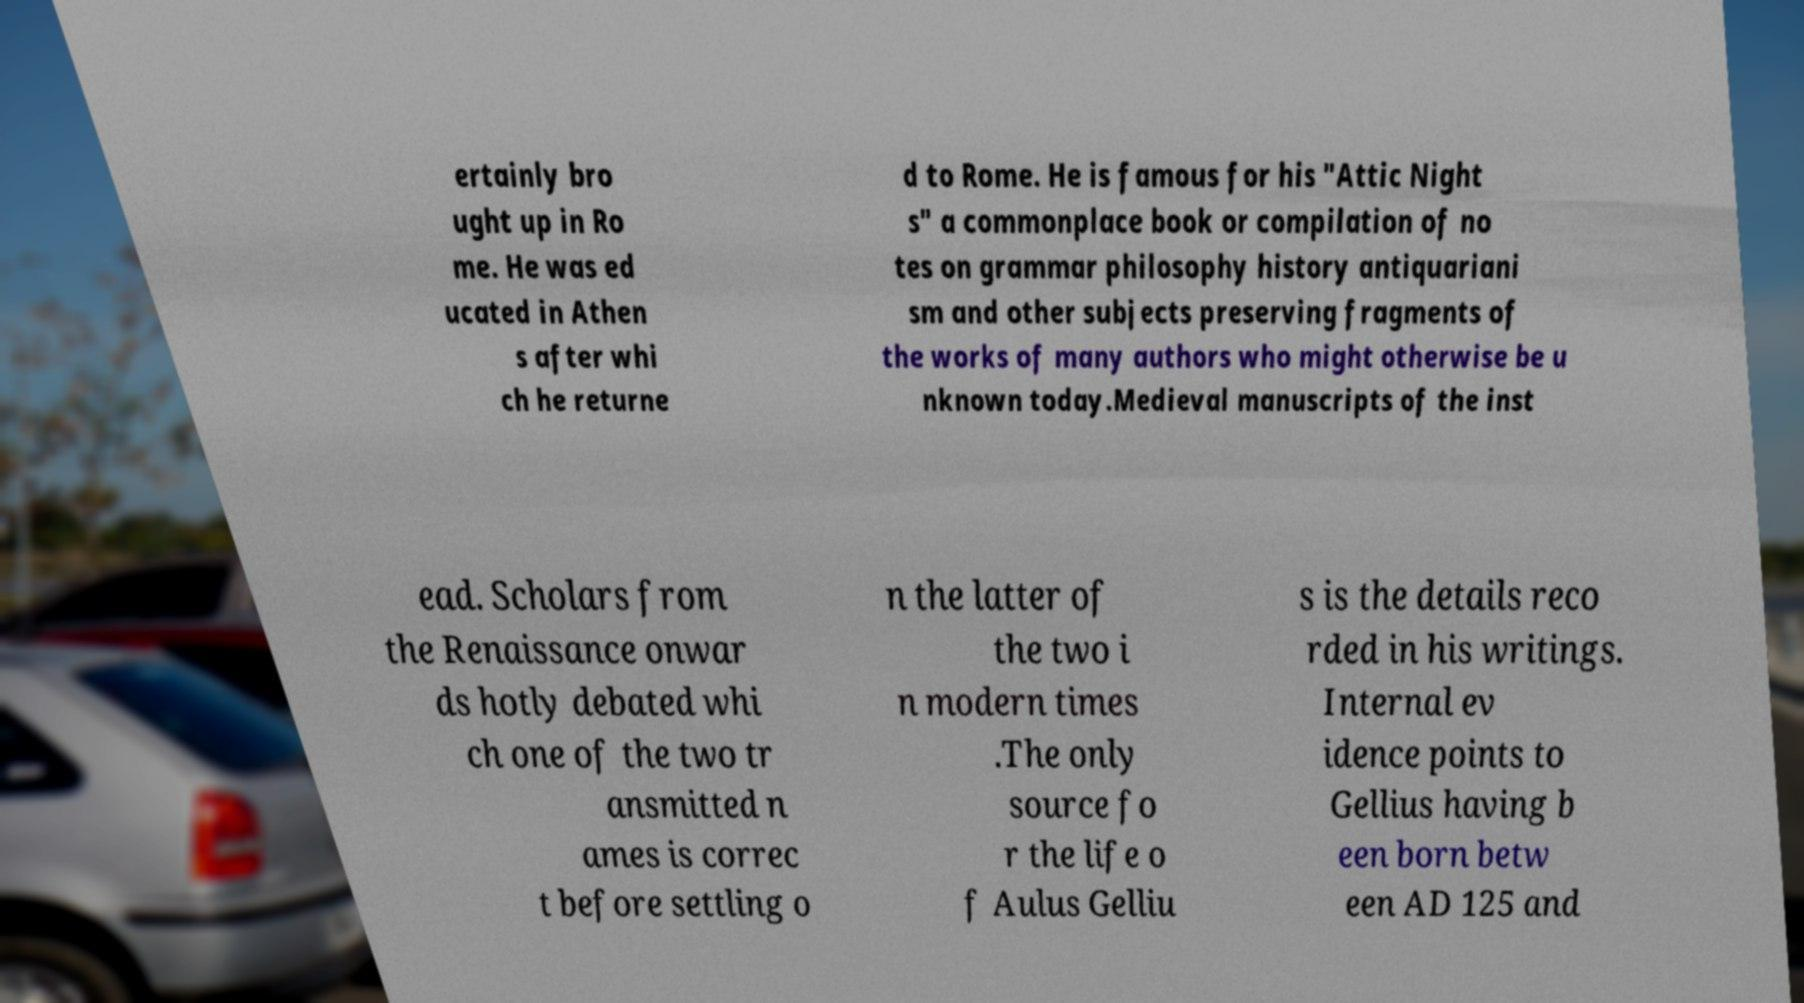What messages or text are displayed in this image? I need them in a readable, typed format. ertainly bro ught up in Ro me. He was ed ucated in Athen s after whi ch he returne d to Rome. He is famous for his "Attic Night s" a commonplace book or compilation of no tes on grammar philosophy history antiquariani sm and other subjects preserving fragments of the works of many authors who might otherwise be u nknown today.Medieval manuscripts of the inst ead. Scholars from the Renaissance onwar ds hotly debated whi ch one of the two tr ansmitted n ames is correc t before settling o n the latter of the two i n modern times .The only source fo r the life o f Aulus Gelliu s is the details reco rded in his writings. Internal ev idence points to Gellius having b een born betw een AD 125 and 